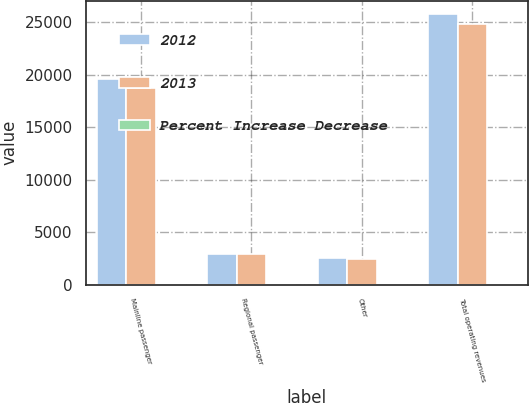<chart> <loc_0><loc_0><loc_500><loc_500><stacked_bar_chart><ecel><fcel>Mainline passenger<fcel>Regional passenger<fcel>Other<fcel>Total operating revenues<nl><fcel>2012<fcel>19594<fcel>2927<fcel>2563<fcel>25760<nl><fcel>2013<fcel>18743<fcel>2914<fcel>2493<fcel>24825<nl><fcel>Percent Increase Decrease<fcel>4.5<fcel>0.5<fcel>2.8<fcel>3.8<nl></chart> 